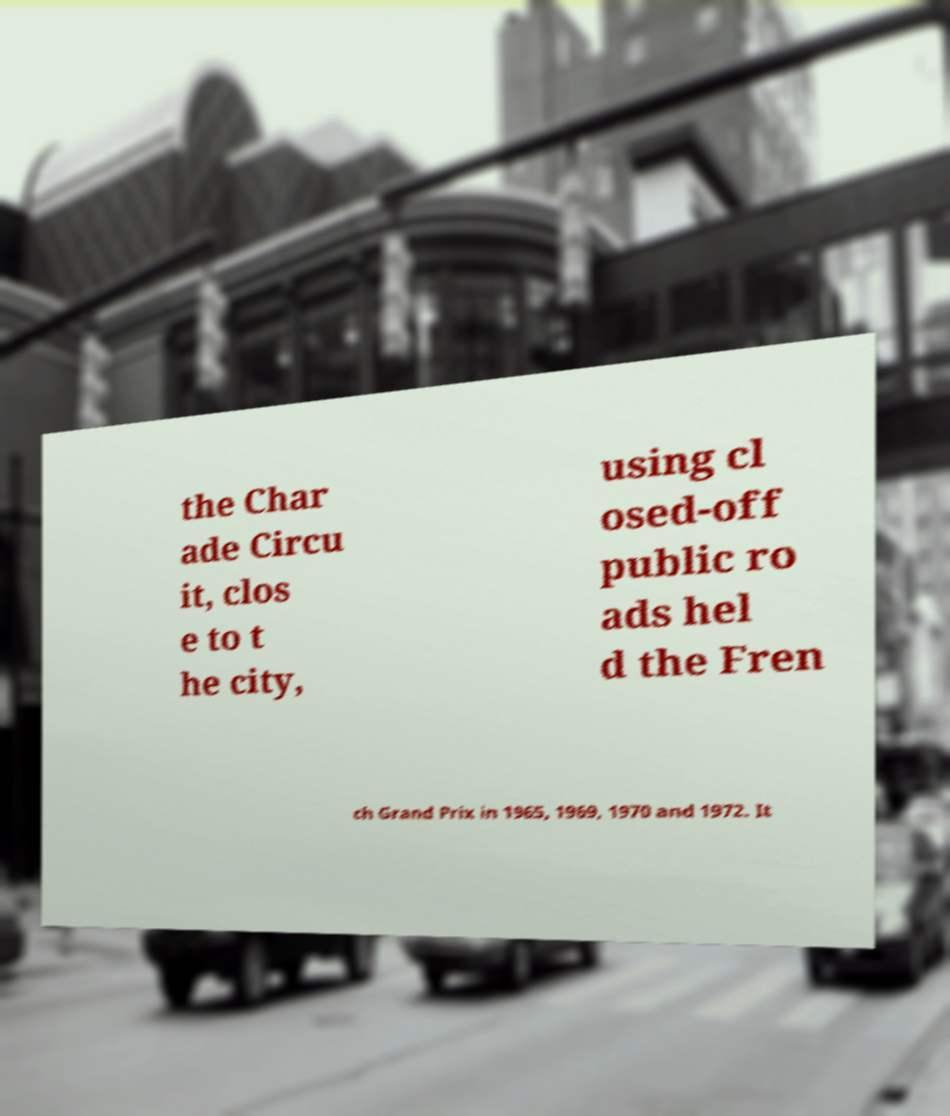For documentation purposes, I need the text within this image transcribed. Could you provide that? the Char ade Circu it, clos e to t he city, using cl osed-off public ro ads hel d the Fren ch Grand Prix in 1965, 1969, 1970 and 1972. It 